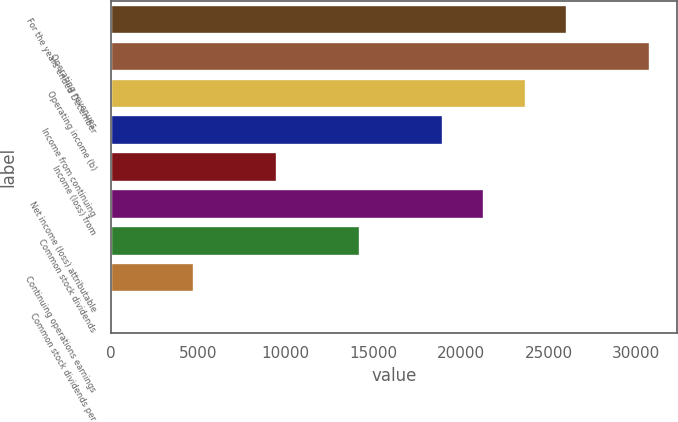Convert chart. <chart><loc_0><loc_0><loc_500><loc_500><bar_chart><fcel>For the years ended December<fcel>Operating revenues<fcel>Operating income (b)<fcel>Income from continuing<fcel>Income (loss) from<fcel>Net income (loss) attributable<fcel>Common stock dividends<fcel>Continuing operations earnings<fcel>Common stock dividends per<nl><fcel>26071<fcel>30810.9<fcel>23701<fcel>18961.1<fcel>9481.34<fcel>21331.1<fcel>14221.2<fcel>4741.44<fcel>1.54<nl></chart> 